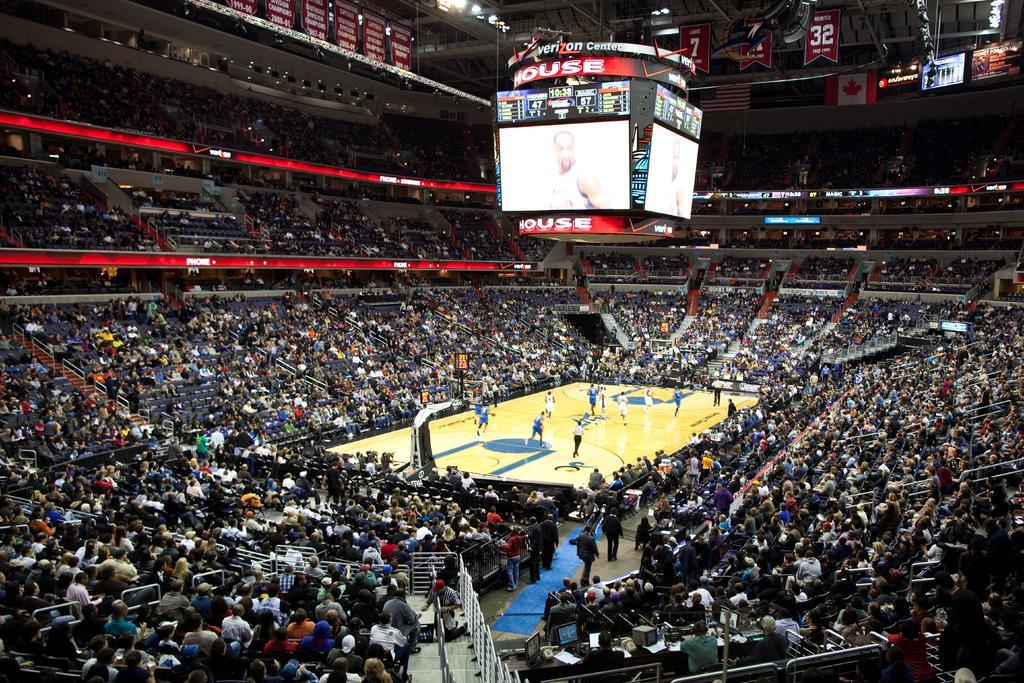How would you summarize this image in a sentence or two? In this picture there is a basketball court in the center of the image and there are people those who are sitting on the chairs around the area of the court and there is a display board at the top side of the image, there are stairs at the bottom side of the image. 